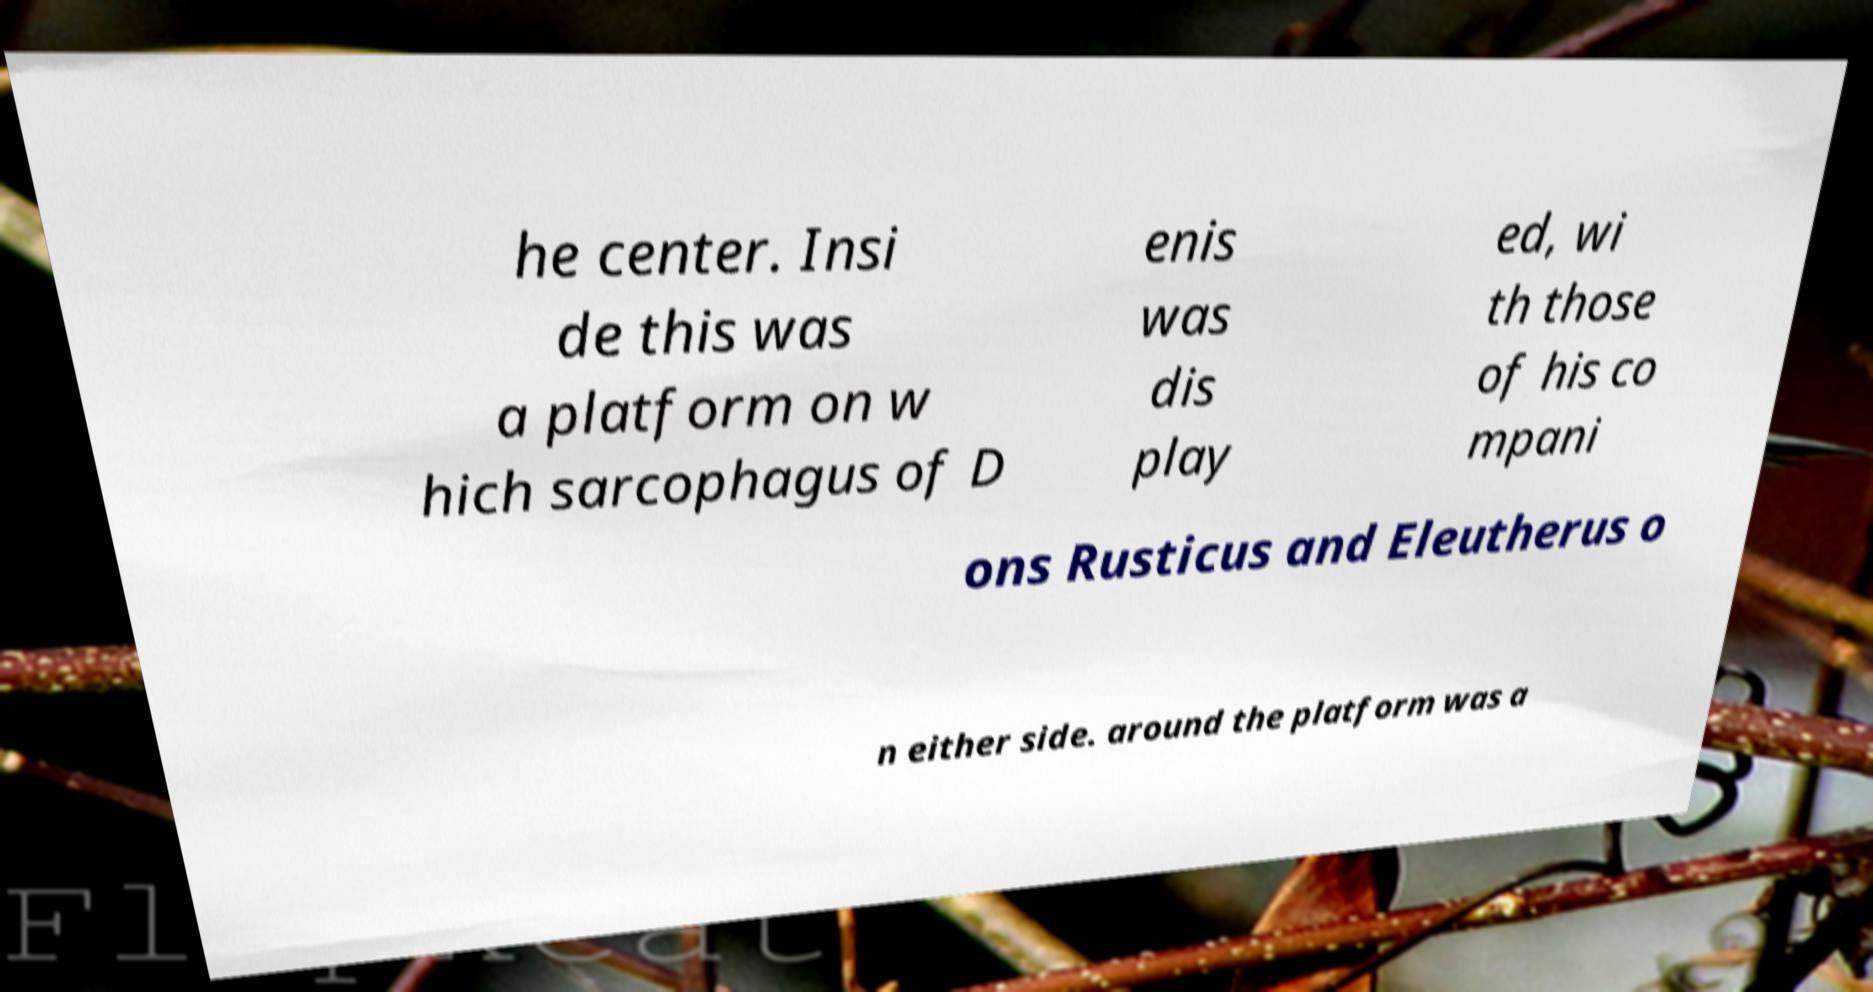Please identify and transcribe the text found in this image. he center. Insi de this was a platform on w hich sarcophagus of D enis was dis play ed, wi th those of his co mpani ons Rusticus and Eleutherus o n either side. around the platform was a 